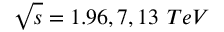Convert formula to latex. <formula><loc_0><loc_0><loc_500><loc_500>\sqrt { s } = 1 . 9 6 , 7 , 1 3 \ T e V</formula> 